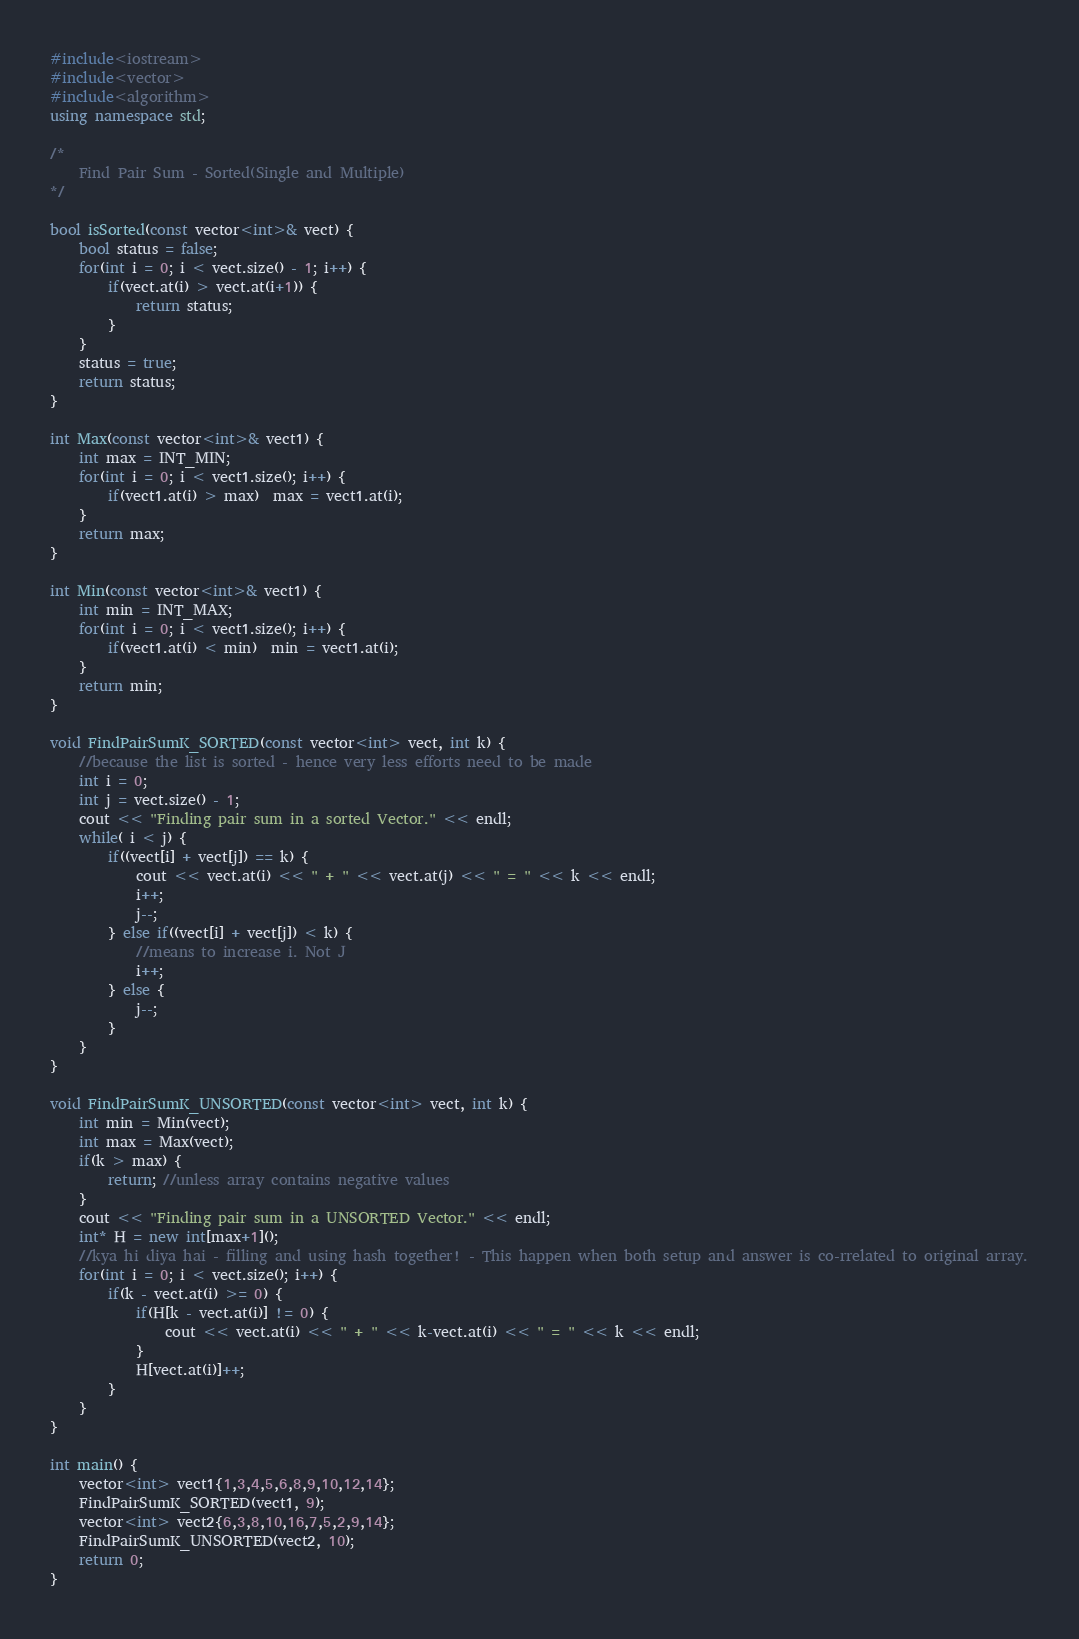<code> <loc_0><loc_0><loc_500><loc_500><_C++_>#include<iostream>
#include<vector>
#include<algorithm>
using namespace std;

/*
    Find Pair Sum - Sorted(Single and Multiple)
*/

bool isSorted(const vector<int>& vect) {
    bool status = false;
    for(int i = 0; i < vect.size() - 1; i++) {
        if(vect.at(i) > vect.at(i+1)) {
            return status;
        }
    }
    status = true;
    return status;
}

int Max(const vector<int>& vect1) {
    int max = INT_MIN;
    for(int i = 0; i < vect1.size(); i++) {
        if(vect1.at(i) > max)  max = vect1.at(i);
    }
    return max;
}

int Min(const vector<int>& vect1) {
    int min = INT_MAX;
    for(int i = 0; i < vect1.size(); i++) {
        if(vect1.at(i) < min)  min = vect1.at(i);
    }
    return min;
}

void FindPairSumK_SORTED(const vector<int> vect, int k) {
    //because the list is sorted - hence very less efforts need to be made
    int i = 0;
    int j = vect.size() - 1;
    cout << "Finding pair sum in a sorted Vector." << endl;
    while( i < j) {
        if((vect[i] + vect[j]) == k) {
            cout << vect.at(i) << " + " << vect.at(j) << " = " << k << endl;
            i++;
            j--;
        } else if((vect[i] + vect[j]) < k) {
            //means to increase i. Not J
            i++;
        } else {
            j--;
        }
    }
}

void FindPairSumK_UNSORTED(const vector<int> vect, int k) {
    int min = Min(vect);
    int max = Max(vect);
    if(k > max) {
        return; //unless array contains negative values
    }
    cout << "Finding pair sum in a UNSORTED Vector." << endl;
    int* H = new int[max+1]();
    //kya hi diya hai - filling and using hash together! - This happen when both setup and answer is co-rrelated to original array.
    for(int i = 0; i < vect.size(); i++) {
        if(k - vect.at(i) >= 0) {
            if(H[k - vect.at(i)] != 0) {
                cout << vect.at(i) << " + " << k-vect.at(i) << " = " << k << endl;
            }
            H[vect.at(i)]++;
        }
    }
}

int main() {
    vector<int> vect1{1,3,4,5,6,8,9,10,12,14};
    FindPairSumK_SORTED(vect1, 9);
    vector<int> vect2{6,3,8,10,16,7,5,2,9,14};
    FindPairSumK_UNSORTED(vect2, 10);
    return 0;
}</code> 